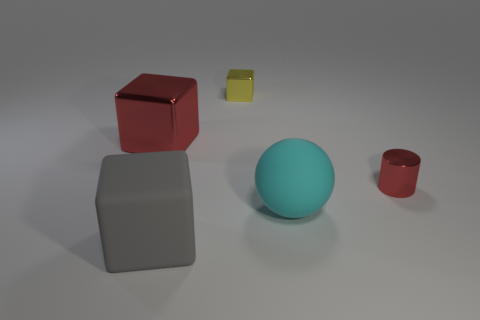Is the number of red things that are on the right side of the large sphere greater than the number of green rubber cubes?
Provide a succinct answer. Yes. What is the cyan thing made of?
Your response must be concise. Rubber. What shape is the yellow thing that is made of the same material as the large red block?
Make the answer very short. Cube. There is a metal block to the left of the big cube in front of the cylinder; how big is it?
Your response must be concise. Large. What color is the metallic object left of the yellow shiny block?
Ensure brevity in your answer.  Red. Is there a large red thing that has the same shape as the tiny yellow thing?
Your answer should be compact. Yes. Is the number of cubes behind the cyan ball less than the number of objects that are in front of the yellow shiny block?
Your answer should be compact. Yes. What is the color of the large sphere?
Provide a succinct answer. Cyan. There is a red shiny object left of the small metallic cylinder; is there a big ball to the right of it?
Offer a very short reply. Yes. What number of other red cubes have the same size as the red shiny block?
Offer a terse response. 0. 